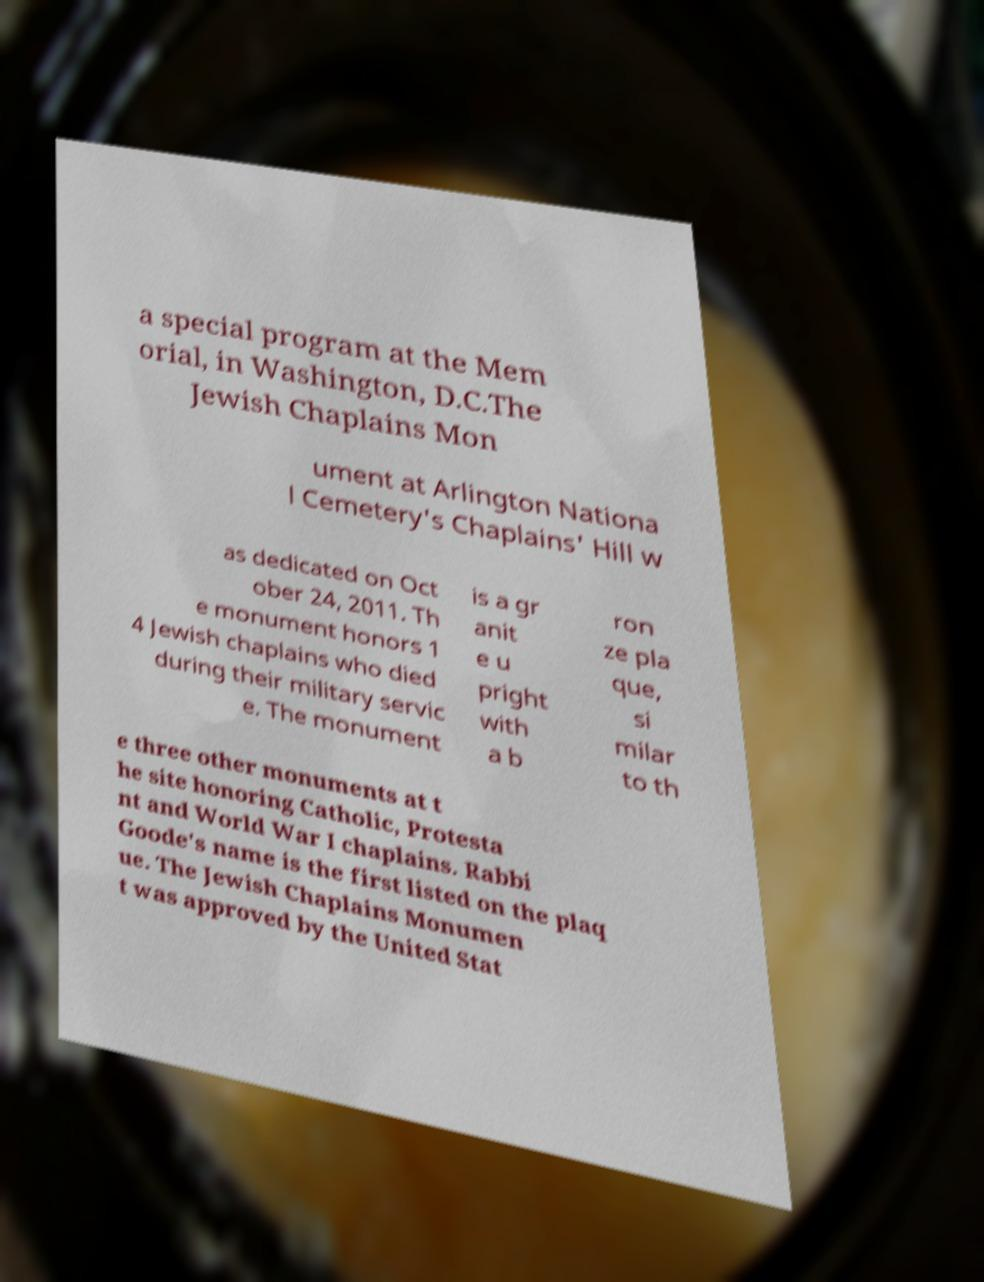There's text embedded in this image that I need extracted. Can you transcribe it verbatim? a special program at the Mem orial, in Washington, D.C.The Jewish Chaplains Mon ument at Arlington Nationa l Cemetery's Chaplains' Hill w as dedicated on Oct ober 24, 2011. Th e monument honors 1 4 Jewish chaplains who died during their military servic e. The monument is a gr anit e u pright with a b ron ze pla que, si milar to th e three other monuments at t he site honoring Catholic, Protesta nt and World War I chaplains. Rabbi Goode's name is the first listed on the plaq ue. The Jewish Chaplains Monumen t was approved by the United Stat 